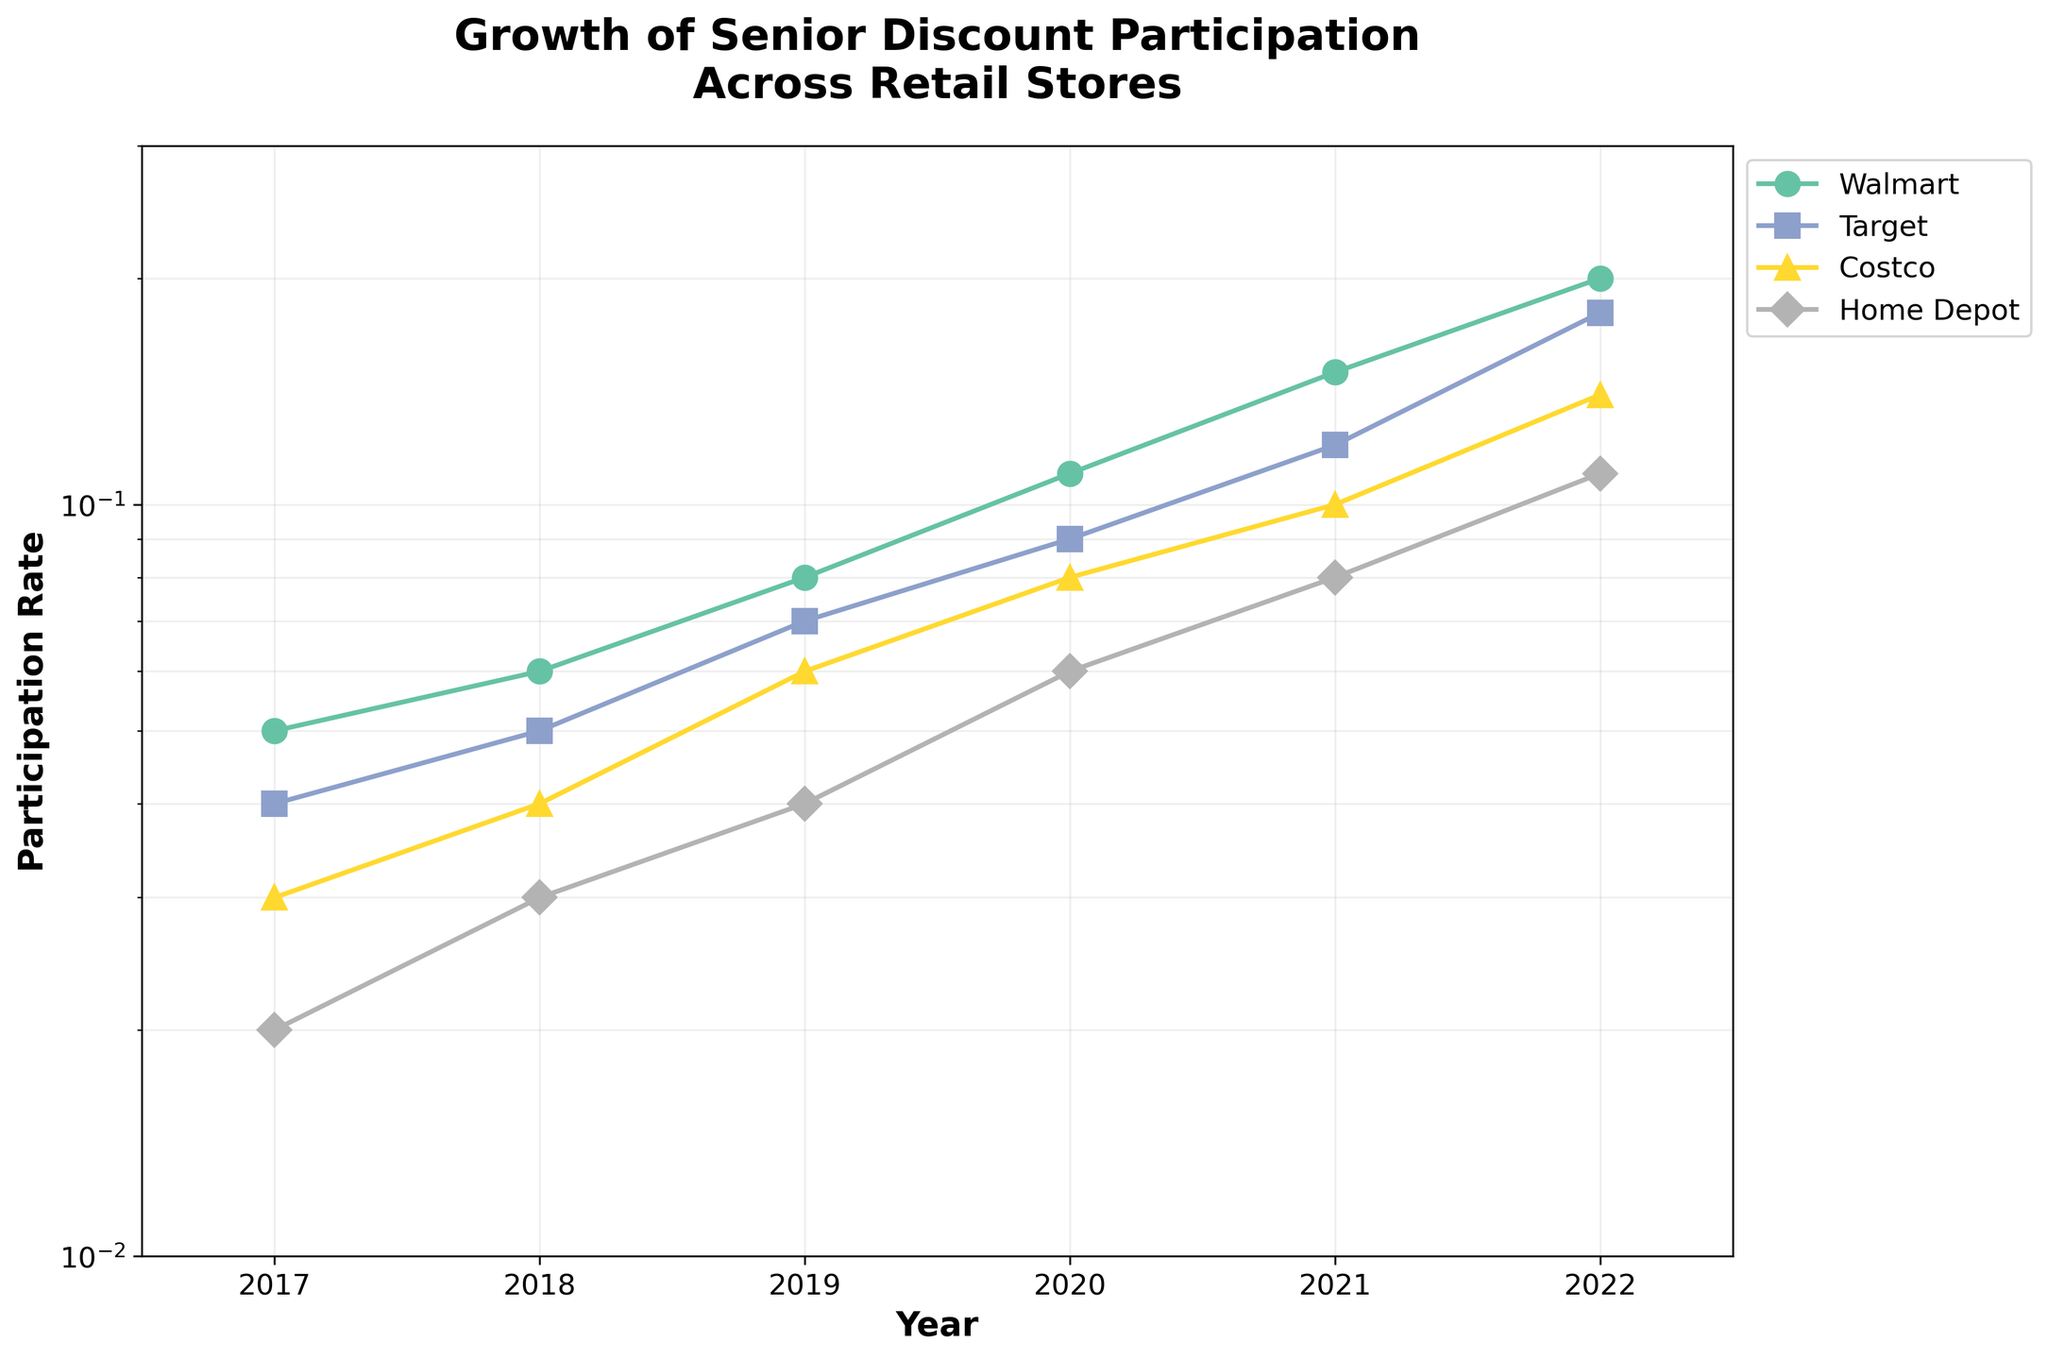what is the title of the figure? The title is displayed at the top of the figure. This helps understand the theme of the data being presented.
Answer: Growth of Senior Discount Participation Across Retail Stores Which store has the highest participation rate in 2022? By looking at the end of the 2022 line for each store, Walmart reaches the highest participation rate on the log scale.
Answer: Walmart How does Target's participation rate in 2021 compare to Home Depot's rate in 2020? Target's participation rate is marked on the vertical log scale in 2021, and Home Depot's rate is marked in 2020. By aligning both rates, Target in 2021 has a higher rate than Home Depot in 2020.
Answer: Higher What is the lowest participation rate in the entire period shown? The lowest marker on the vertical axis within the plot's range belongs to Home Depot in 2017 with a rate of 0.02.
Answer: 0.02 Which store had the most significant growth between 2017 and 2022? Each store's growth is compared by finding the difference between their rates in 2022 and 2017. Walmart has the largest increase from 0.05 to 0.20, which is 0.15.
Answer: Walmart What can you deduce about Costco's growth trend compared to Walmart? By comparing the slopes of the lines for Walmart and Costco, Walmart's line is steeper than Costco's, indicating Walmart had a faster growth rate over the years.
Answer: Walmart has a faster growth rate What are the X and Y ranges in the figure? The X-axis represents the years from 2017 to 2022, and the Y-axis shows the participation rate from 0.01 to 0.3 on a log scale.
Answer: X: 2017-2022, Y: 0.01-0.3 If you look at 2018, which store had the second lowest participation rate? Identifying the markers in 2018, Home Depot has the lowest, and Costco has the second lowest rate at 0.04.
Answer: Costco Between 2018 and 2019, which store had the highest change in participation rate? Calculating the differences between 2018 and 2019 for each store, Walmart's rate changed by 0.02 (0.08 - 0.06), the highest among all stores.
Answer: Walmart 